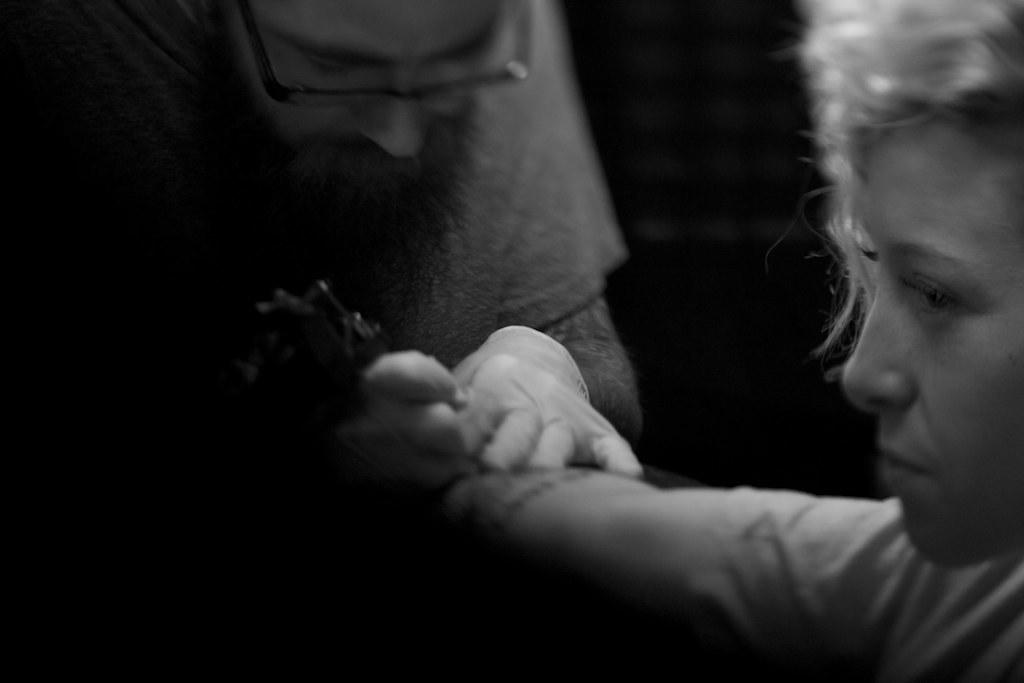How many people are in the image? There are two persons in the image. What is one person doing with an object? One person is holding an object. What type of pear is being used to soothe the person's throat in the image? There is no pear or reference to a throat in the image; it only shows two persons and one person holding an object. 